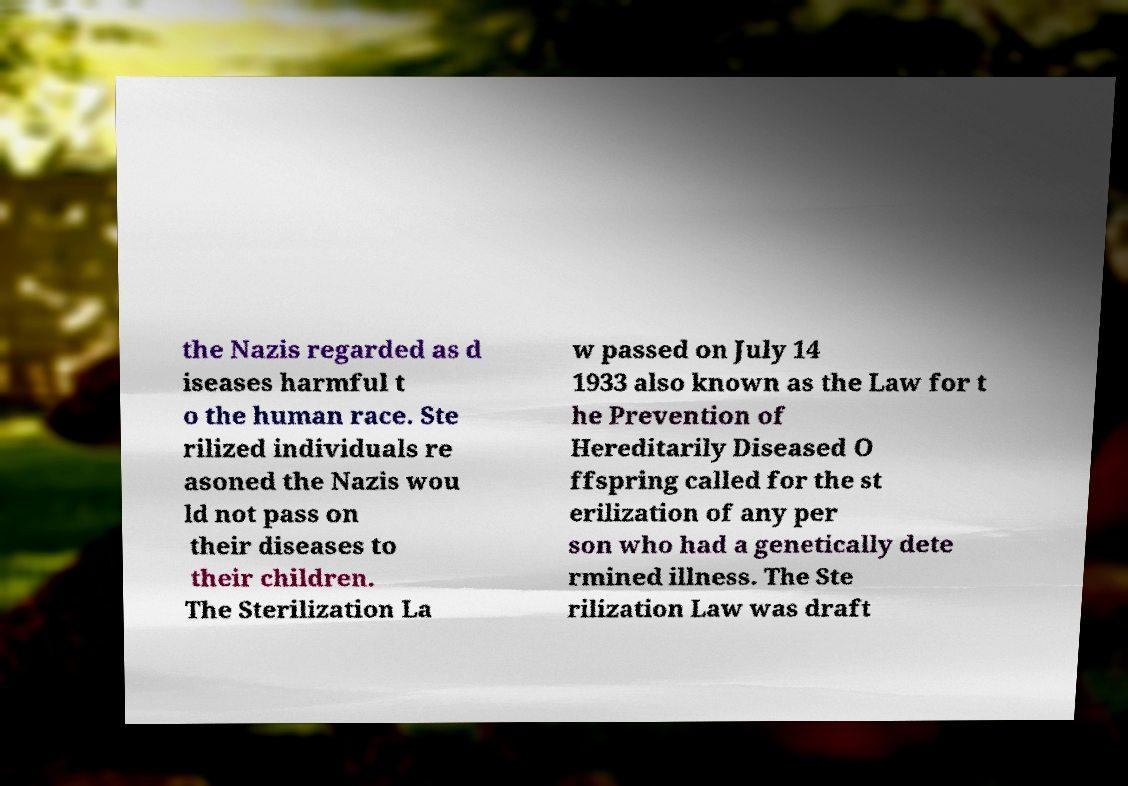For documentation purposes, I need the text within this image transcribed. Could you provide that? the Nazis regarded as d iseases harmful t o the human race. Ste rilized individuals re asoned the Nazis wou ld not pass on their diseases to their children. The Sterilization La w passed on July 14 1933 also known as the Law for t he Prevention of Hereditarily Diseased O ffspring called for the st erilization of any per son who had a genetically dete rmined illness. The Ste rilization Law was draft 